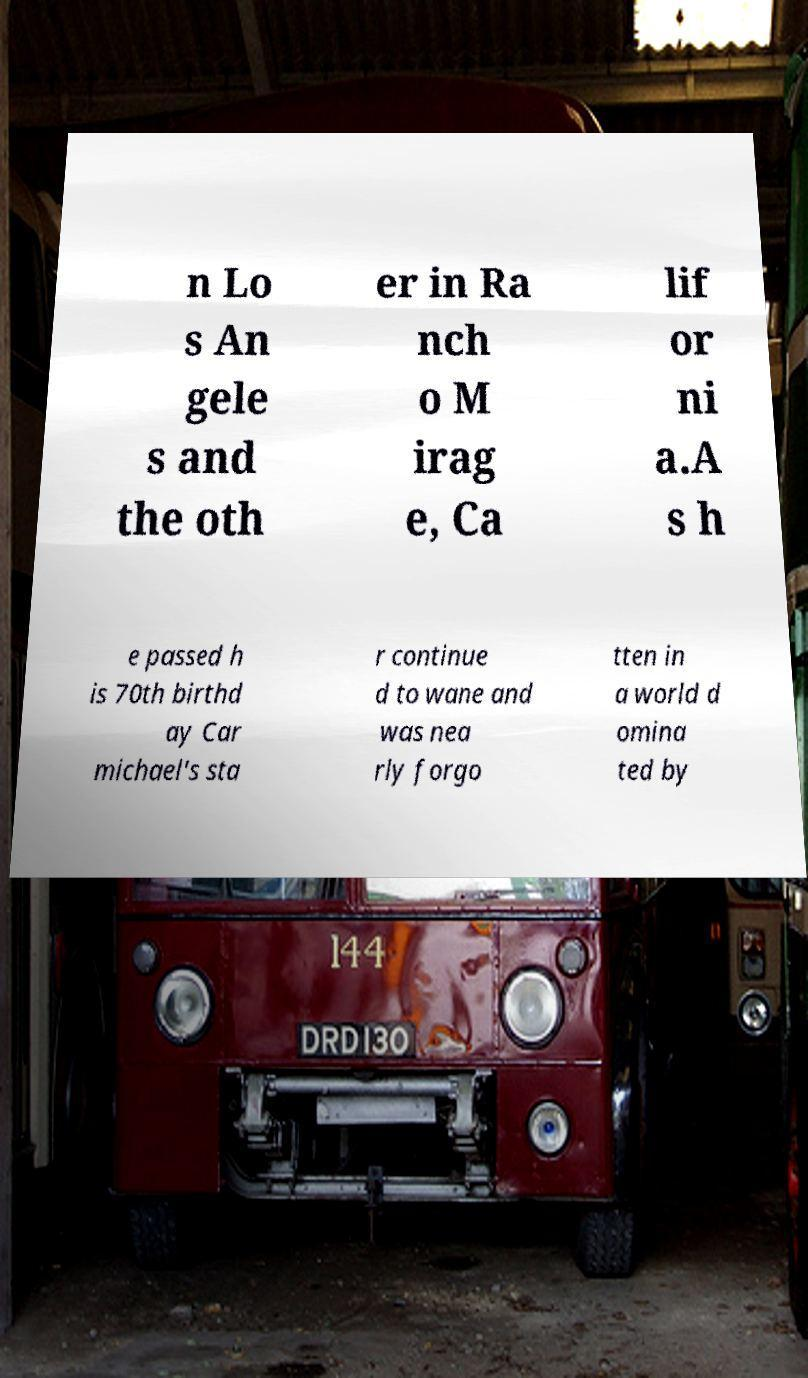What messages or text are displayed in this image? I need them in a readable, typed format. n Lo s An gele s and the oth er in Ra nch o M irag e, Ca lif or ni a.A s h e passed h is 70th birthd ay Car michael's sta r continue d to wane and was nea rly forgo tten in a world d omina ted by 